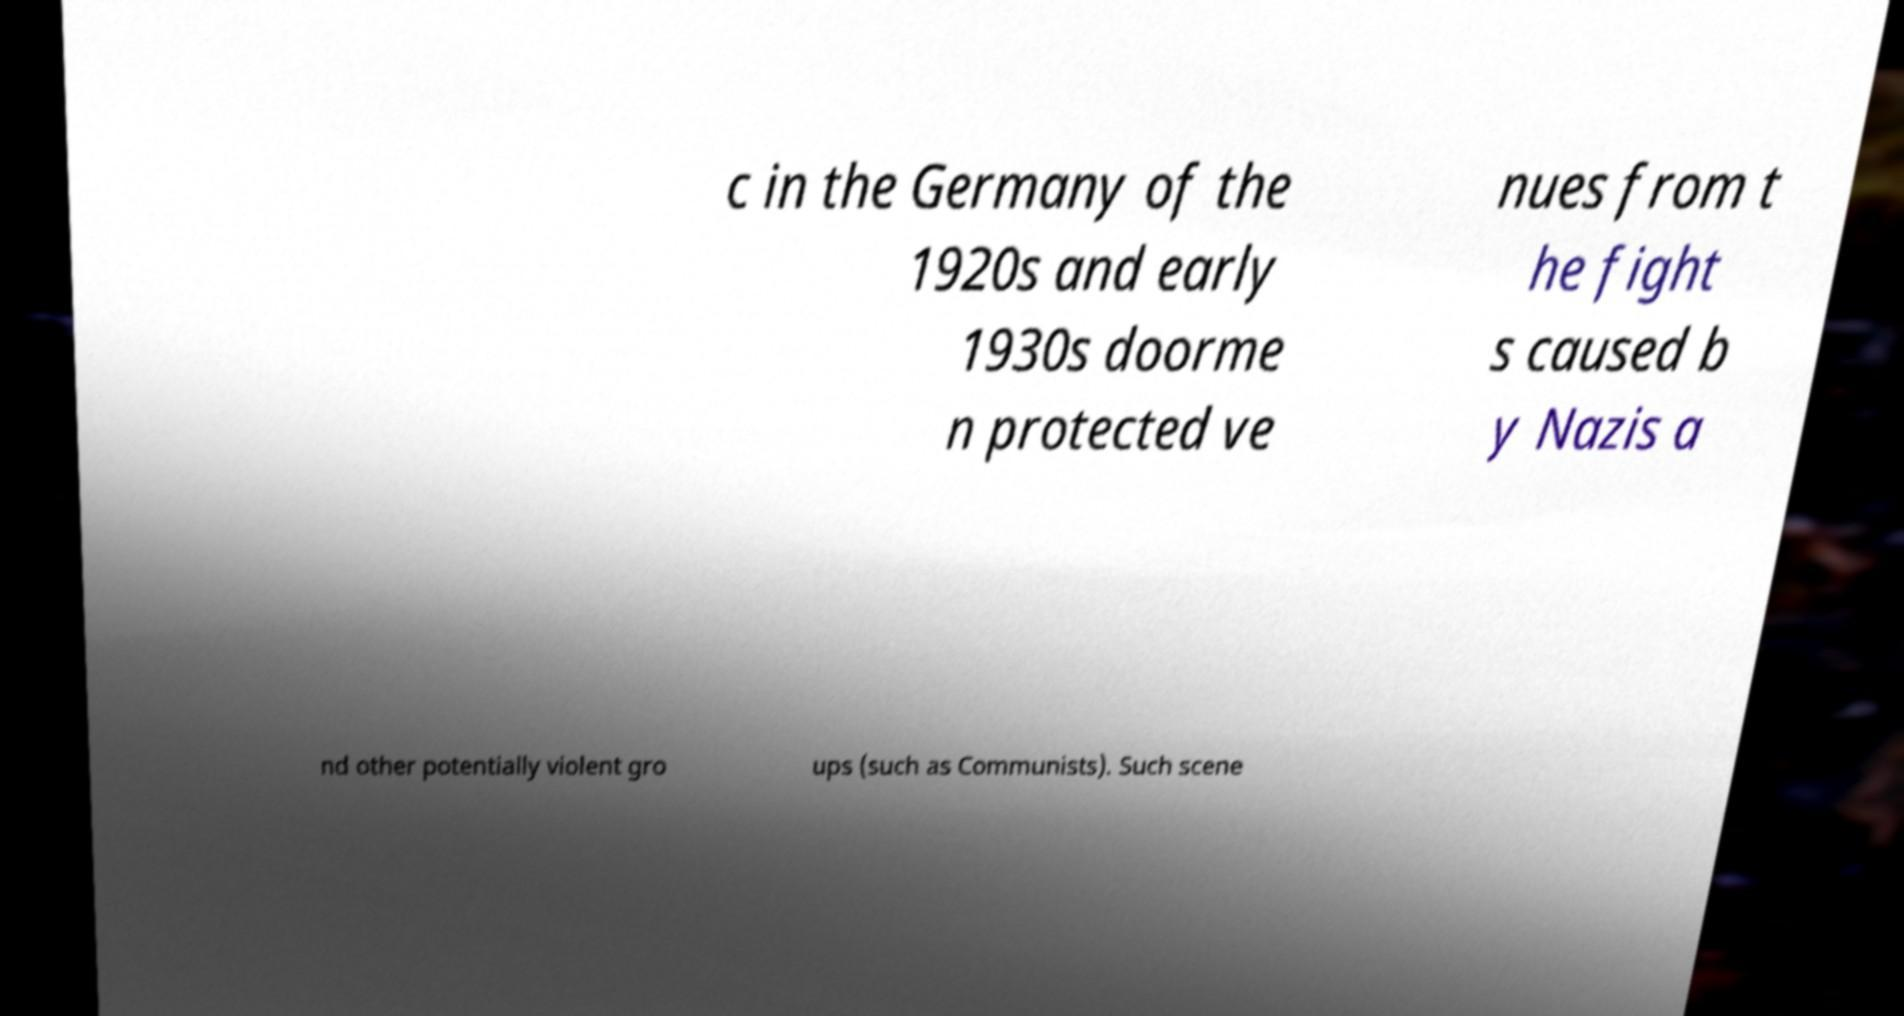Could you extract and type out the text from this image? c in the Germany of the 1920s and early 1930s doorme n protected ve nues from t he fight s caused b y Nazis a nd other potentially violent gro ups (such as Communists). Such scene 